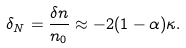<formula> <loc_0><loc_0><loc_500><loc_500>\delta _ { N } = \frac { \delta n } { n _ { 0 } } \approx - 2 ( 1 - \alpha ) \kappa .</formula> 